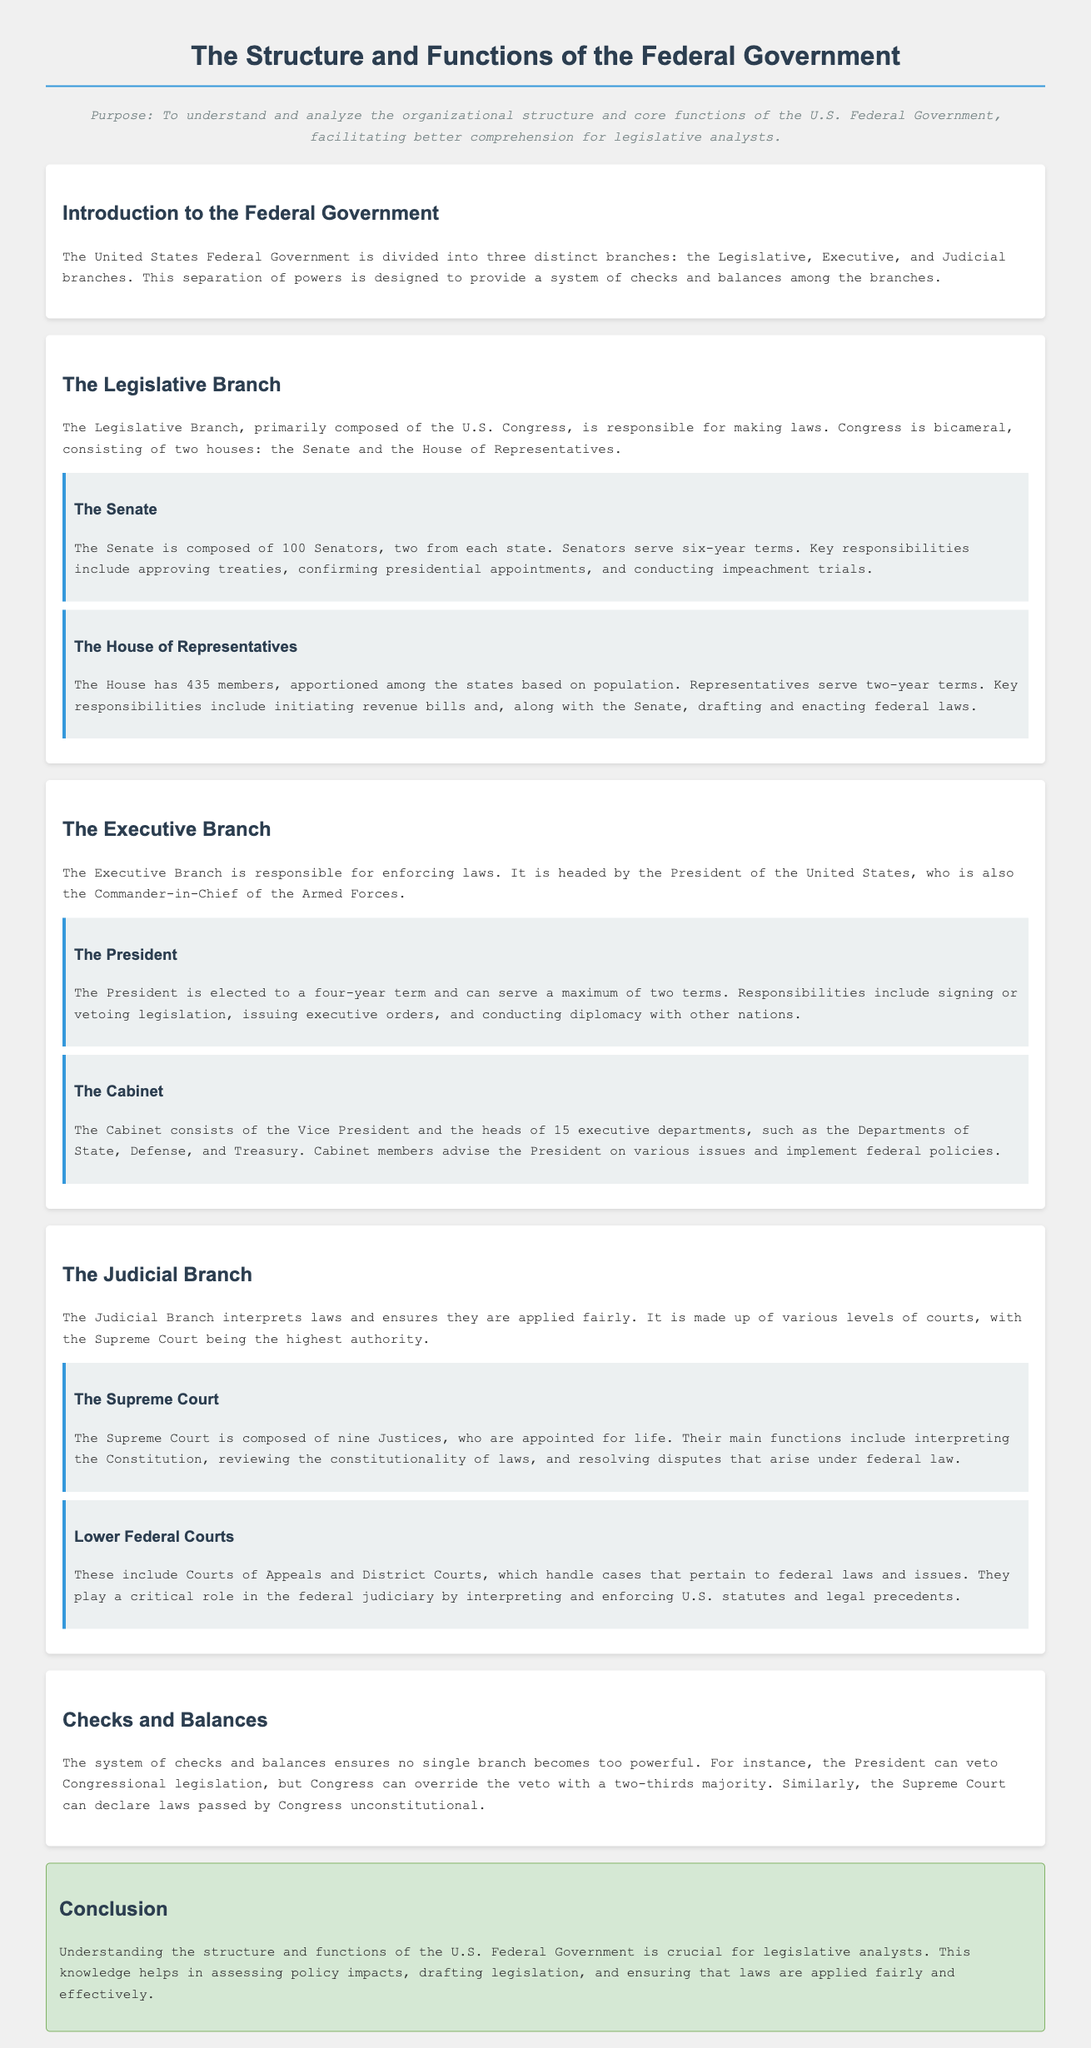What are the three branches of the Federal Government? The document states that the Federal Government is divided into three distinct branches: the Legislative, Executive, and Judicial branches.
Answer: Legislative, Executive, Judicial How many Senators are there in the Senate? The document mentions that the Senate is composed of 100 Senators, two from each state.
Answer: 100 What is the term length for a House Representative? According to the document, Representatives serve two-year terms.
Answer: Two years Who is the head of the Executive Branch? The document states that the Executive Branch is headed by the President of the United States.
Answer: President What is the primary role of the Judicial Branch? The document describes that the Judicial Branch interprets laws and ensures they are applied fairly.
Answer: Interprets laws What can Congress do to override a presidential veto? The document points out that Congress can override a veto with a two-thirds majority.
Answer: Two-thirds majority How many Justices are on the Supreme Court? The document states that the Supreme Court is composed of nine Justices.
Answer: Nine What are the main components of the Cabinet? The document explains that the Cabinet consists of the Vice President and the heads of 15 executive departments.
Answer: Vice President and heads of 15 executive departments What ensures that no single branch becomes too powerful? The document mentions the system of checks and balances as key to preventing any single branch from becoming too powerful.
Answer: Checks and balances 